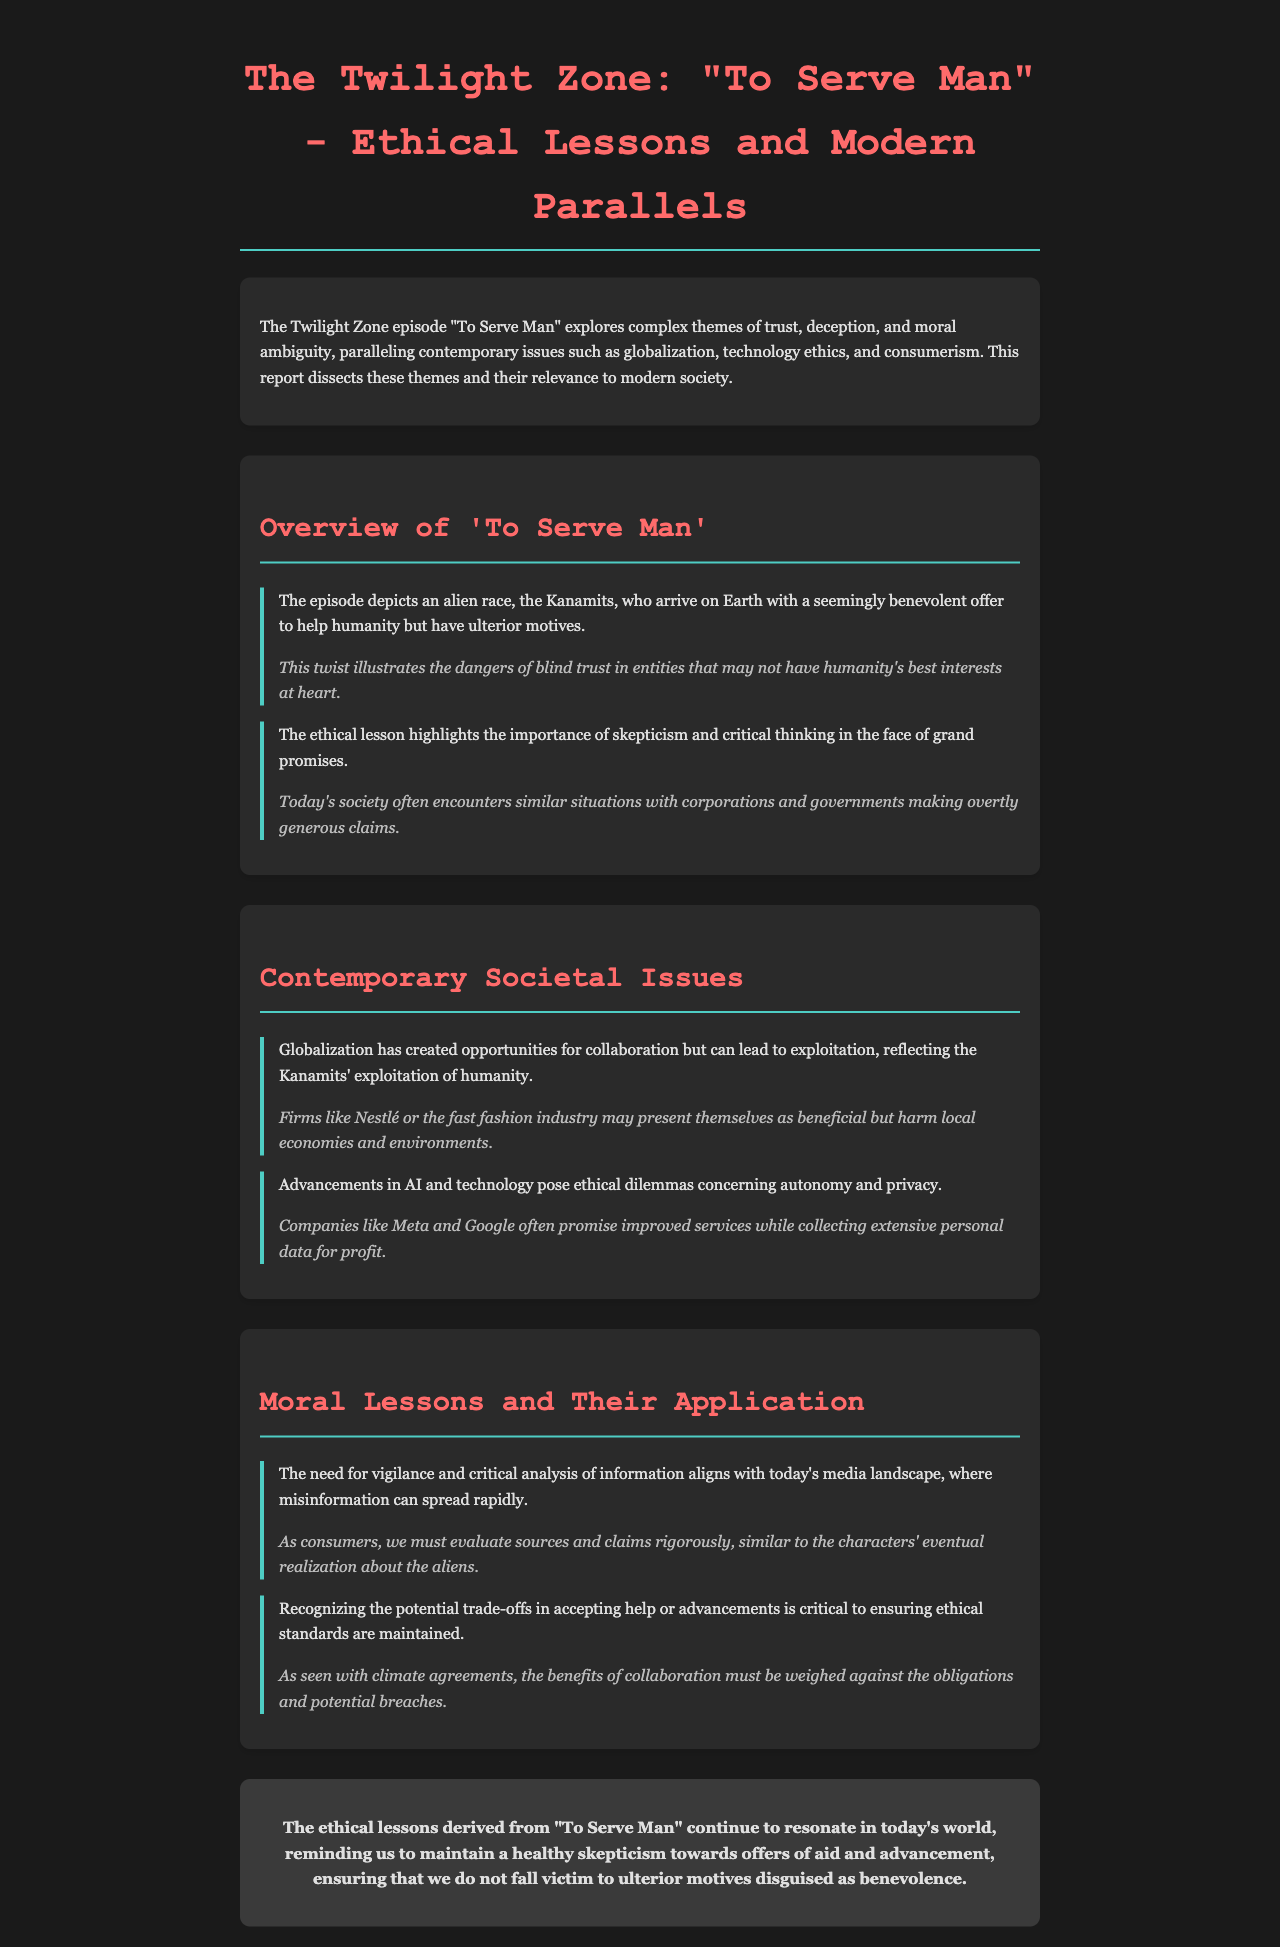What is the title of the episode discussed? The title mentioned in the document is specifically highlighted in the section header.
Answer: To Serve Man What do the Kanamits offer to humanity? The document states that the Kanamits arrive with a seemingly benevolent offer, which is outlined in the overview section.
Answer: Help humanity What ethical lesson is emphasized regarding trust? The report discusses an ethical lesson that underscores the importance of critical thinking and skepticism towards grand promises.
Answer: Skepticism and critical thinking Which contemporary issue is compared to globalization? The document relates modern exploitation issues to the themes present in "To Serve Man."
Answer: Exploitation What is one example given of corporate exploitation? An example provided in the document illustrates the negative effects of certain corporations pretending to be beneficial.
Answer: Nestlé What effect does the episode highlight regarding deception? The report emphasizes a significant aspect of deception as it relates to the characters' realization about the aliens.
Answer: Blind trust What current technology issue is mentioned? The document identifies a pressing issue in today's society resulting from advancements in technology, particularly concerning data.
Answer: AI and technology ethics What is the overall conclusion of the report? The conclusion section summarizes the key ethical lessons from the episode as they apply to modern contexts.
Answer: Healthy skepticism What are the potential implications of accepting help according to the report? The document discusses the necessity of weighing benefits against obligations in the context of collaborations.
Answer: Trade-offs in accepting help 